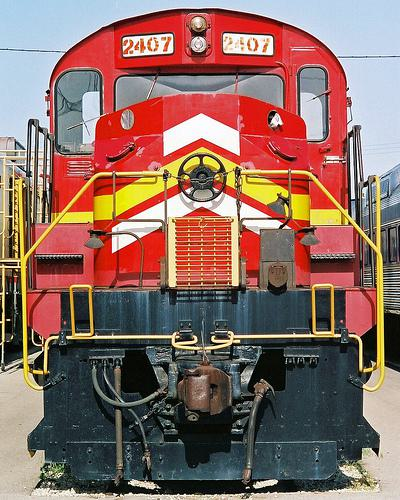Is there a train in the image? Yes, there is a train in the image. It's a red locomotive with white and yellow detailing, featuring the number 2407 near the top. The train appears to be stationary with a series of switches and mechanisms visible in the foreground, typical of a diesel engine's control system. 